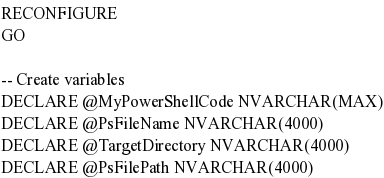<code> <loc_0><loc_0><loc_500><loc_500><_SQL_>RECONFIGURE
GO

-- Create variables
DECLARE @MyPowerShellCode NVARCHAR(MAX)
DECLARE @PsFileName NVARCHAR(4000)
DECLARE @TargetDirectory NVARCHAR(4000)
DECLARE @PsFilePath NVARCHAR(4000)</code> 